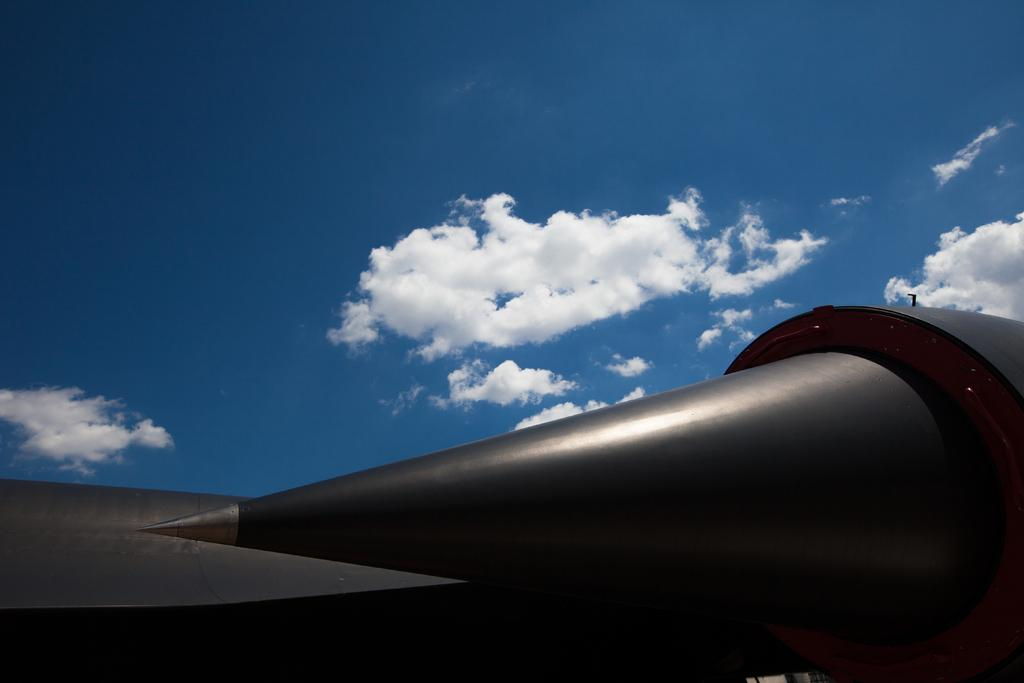What is the color of the object at the bottom of the image? The object at the bottom of the image is black. What can be seen at the top of the image? The sky is visible at the top of the image. What is present in the sky? Clouds are present in the sky. What arithmetic problem is the mom solving in the image? There is no mom or arithmetic problem present in the image. What type of print is visible on the object at the bottom of the image? There is no print visible on the black object at the bottom of the image. 